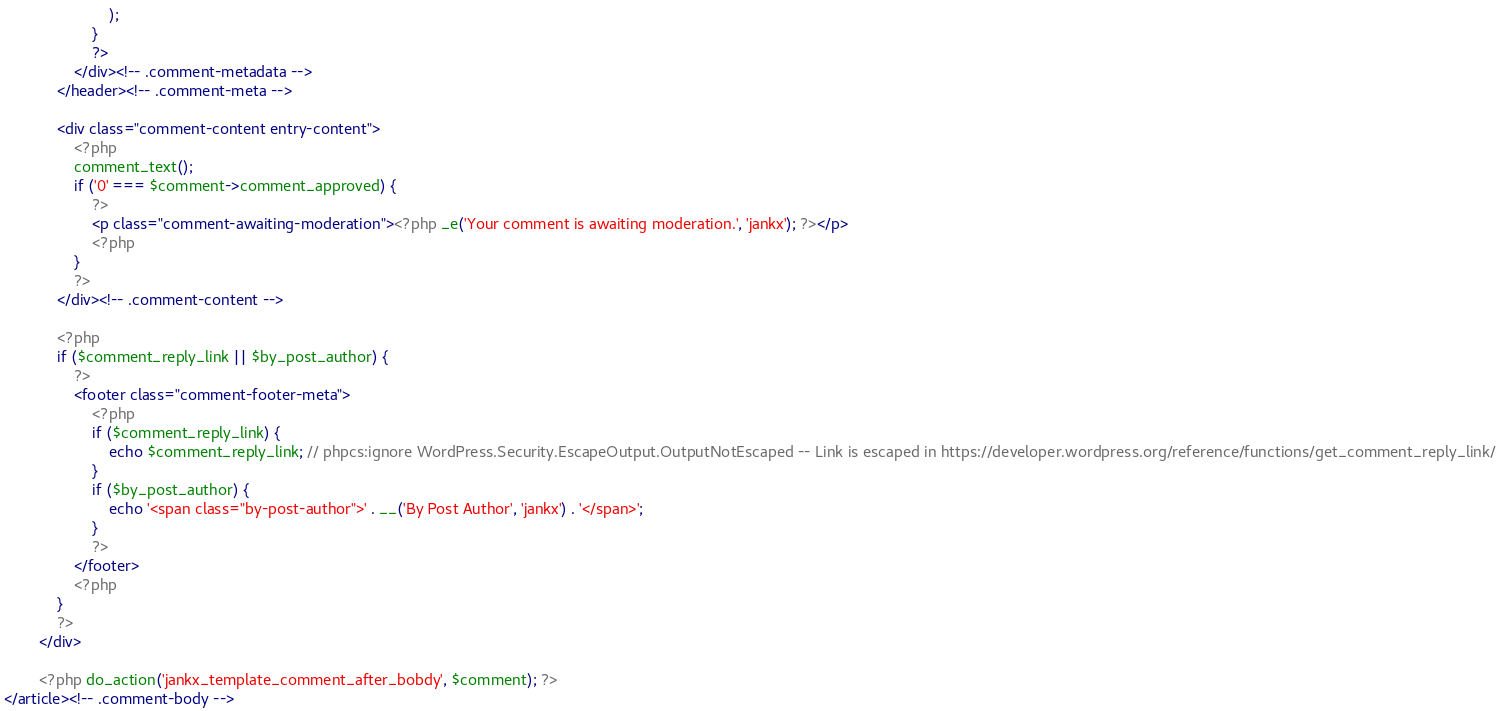Convert code to text. <code><loc_0><loc_0><loc_500><loc_500><_PHP_>                        );
                    }
                    ?>
                </div><!-- .comment-metadata -->
            </header><!-- .comment-meta -->

            <div class="comment-content entry-content">
                <?php
                comment_text();
                if ('0' === $comment->comment_approved) {
                    ?>
                    <p class="comment-awaiting-moderation"><?php _e('Your comment is awaiting moderation.', 'jankx'); ?></p>
                    <?php
                }
                ?>
            </div><!-- .comment-content -->

            <?php
            if ($comment_reply_link || $by_post_author) {
                ?>
                <footer class="comment-footer-meta">
                    <?php
                    if ($comment_reply_link) {
                        echo $comment_reply_link; // phpcs:ignore WordPress.Security.EscapeOutput.OutputNotEscaped -- Link is escaped in https://developer.wordpress.org/reference/functions/get_comment_reply_link/
                    }
                    if ($by_post_author) {
                        echo '<span class="by-post-author">' . __('By Post Author', 'jankx') . '</span>';
                    }
                    ?>
                </footer>
                <?php
            }
            ?>
        </div>

        <?php do_action('jankx_template_comment_after_bobdy', $comment); ?>
</article><!-- .comment-body -->
</code> 